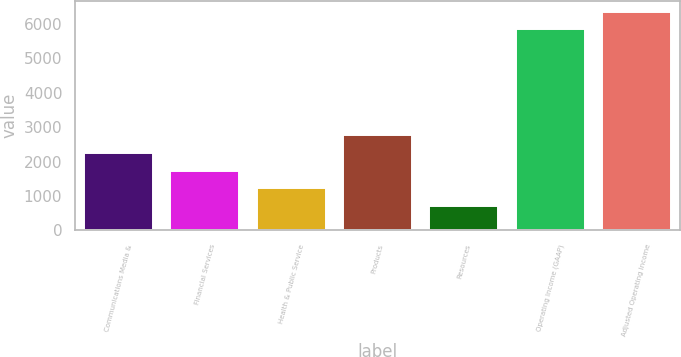Convert chart to OTSL. <chart><loc_0><loc_0><loc_500><loc_500><bar_chart><fcel>Communications Media &<fcel>Financial Services<fcel>Health & Public Service<fcel>Products<fcel>Resources<fcel>Operating Income (GAAP)<fcel>Adjusted Operating Income<nl><fcel>2252.8<fcel>1740.2<fcel>1227.6<fcel>2765.4<fcel>715<fcel>5841<fcel>6353.6<nl></chart> 